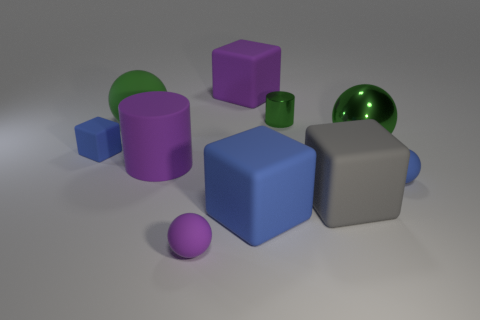The tiny sphere that is left of the purple rubber object behind the large green ball that is to the left of the large cylinder is made of what material?
Make the answer very short. Rubber. The green thing that is the same size as the green matte ball is what shape?
Keep it short and to the point. Sphere. What number of objects are tiny blue matte cubes or blue rubber cubes to the right of the big purple matte cylinder?
Ensure brevity in your answer.  2. Does the big green object to the left of the purple matte cube have the same material as the large purple thing that is behind the large matte ball?
Ensure brevity in your answer.  Yes. The big thing that is the same color as the big cylinder is what shape?
Give a very brief answer. Cube. What number of blue objects are either rubber cylinders or cylinders?
Keep it short and to the point. 0. The green rubber thing is what size?
Offer a terse response. Large. Is the number of small blocks that are in front of the big purple rubber cube greater than the number of big green blocks?
Provide a succinct answer. Yes. How many big blocks are to the right of the green metallic cylinder?
Make the answer very short. 1. Is there another rubber ball that has the same size as the blue rubber ball?
Offer a terse response. Yes. 